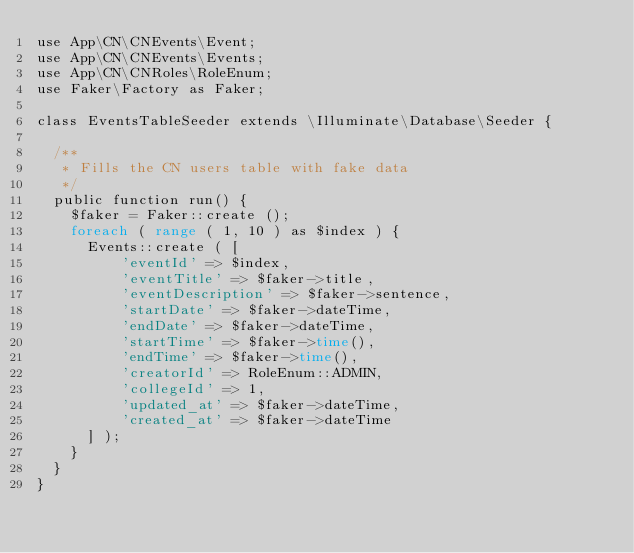<code> <loc_0><loc_0><loc_500><loc_500><_PHP_>use App\CN\CNEvents\Event;
use App\CN\CNEvents\Events;
use App\CN\CNRoles\RoleEnum;
use Faker\Factory as Faker;

class EventsTableSeeder extends \Illuminate\Database\Seeder {
	
	/**
	 * Fills the CN users table with fake data
	 */
	public function run() {
		$faker = Faker::create ();
		foreach ( range ( 1, 10 ) as $index ) {
			Events::create ( [
					'eventId' => $index,
					'eventTitle' => $faker->title,
					'eventDescription' => $faker->sentence,
					'startDate' => $faker->dateTime,
					'endDate' => $faker->dateTime,
					'startTime' => $faker->time(),
					'endTime' => $faker->time(),
					'creatorId' => RoleEnum::ADMIN,
					'collegeId' => 1,
					'updated_at' => $faker->dateTime,
					'created_at' => $faker->dateTime
			] );
		}
	}
}</code> 